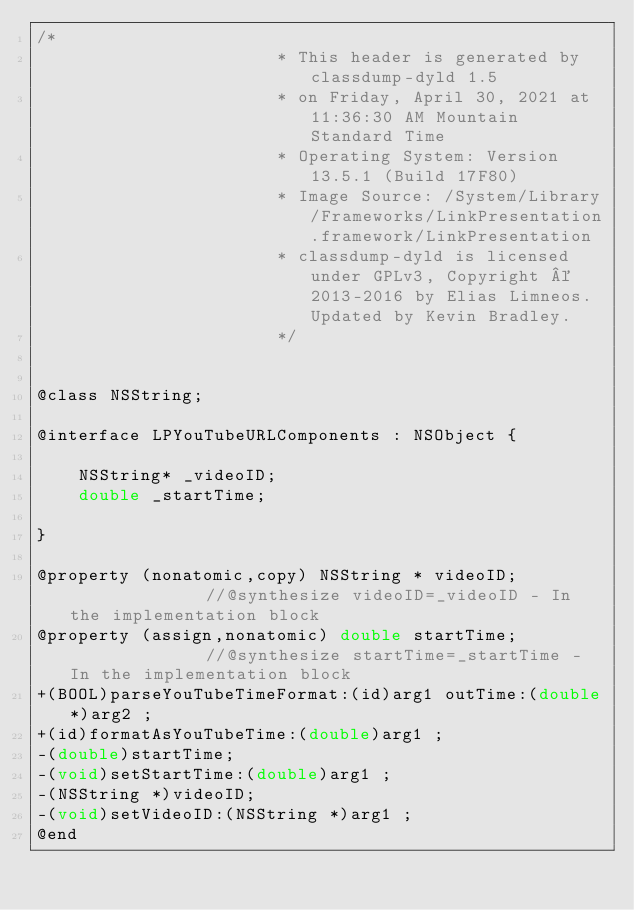Convert code to text. <code><loc_0><loc_0><loc_500><loc_500><_C_>/*
                       * This header is generated by classdump-dyld 1.5
                       * on Friday, April 30, 2021 at 11:36:30 AM Mountain Standard Time
                       * Operating System: Version 13.5.1 (Build 17F80)
                       * Image Source: /System/Library/Frameworks/LinkPresentation.framework/LinkPresentation
                       * classdump-dyld is licensed under GPLv3, Copyright © 2013-2016 by Elias Limneos. Updated by Kevin Bradley.
                       */


@class NSString;

@interface LPYouTubeURLComponents : NSObject {

	NSString* _videoID;
	double _startTime;

}

@property (nonatomic,copy) NSString * videoID;              //@synthesize videoID=_videoID - In the implementation block
@property (assign,nonatomic) double startTime;              //@synthesize startTime=_startTime - In the implementation block
+(BOOL)parseYouTubeTimeFormat:(id)arg1 outTime:(double*)arg2 ;
+(id)formatAsYouTubeTime:(double)arg1 ;
-(double)startTime;
-(void)setStartTime:(double)arg1 ;
-(NSString *)videoID;
-(void)setVideoID:(NSString *)arg1 ;
@end

</code> 